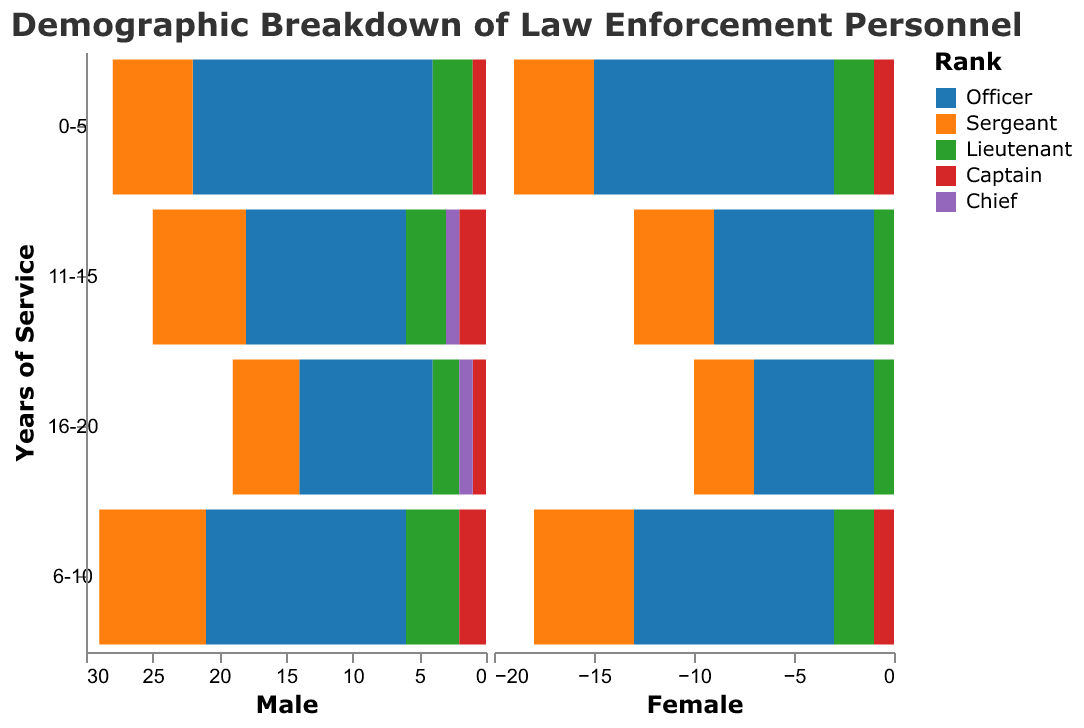What is the title of the figure? The title of the figure is provided at the top of the chart. It reads "Demographic Breakdown of Law Enforcement Personnel."
Answer: Demographic Breakdown of Law Enforcement Personnel In the "6-10 years" category, which rank has the most female personnel? By examining the "6-10 years" group on the female side, the rank of "Officer" has the largest bar, indicating the most female personnel.
Answer: Officer How many male Captains have 11-15 years of service? Locate the "11-15 years" category on the male side and look for the rank "Captain." The bar height represents the count, which is 2 males.
Answer: 2 Comparing male and female Lieutenants with 16-20 years of service, which gender has more? For "16-20 years" Lieutenants, compare the lengths of the bars. The male side shows a value of 2, while the female side shows 1. Males have more.
Answer: Male Are there any female Chiefs with 11-15 years of service? Look at the pyramid section for Chiefs under "11-15 years" on the female side. There is no corresponding bar, indicating zero female personnel.
Answer: No What is the combined number of male and female Officers with 0-5 years of service? Add the values for male Officers (18) and female Officers (12) in the "0-5 years" category. The combined number is 18 + 12 = 30.
Answer: 30 What rank shows the least number of females across all years of service? Find the smallest bars on the female side across all years of service. The rank with the least number of females is "Chief" (0 for both 11-15 and 16-20 years).
Answer: Chief Which rank has an equal number of male and female personnel within the 0-5 year category? Compare the lengths of the bars for males and females within the "0-5 years" category. The rank "Captain" has both bars equal, indicating 1 male and 1 female.
Answer: Captain How many more male Sergeants are there than male Lieutenants in the 6-10 years category? Subtract the number of male Lieutenants (4) from the number of male Sergeants (8) in the "6-10 years" category. The result is 8 - 4 = 4 more male Sergeants.
Answer: 4 Across all ranks, which year of service category has the most male personnel? Add the numbers of males across all ranks for each year of service category and identify the maximum. "0-5 years" has the totals: Officer (18) + Sergeant (6) + Lieutenant (3) + Captain (1) = 28 males, which is the highest.
Answer: 0-5 years 